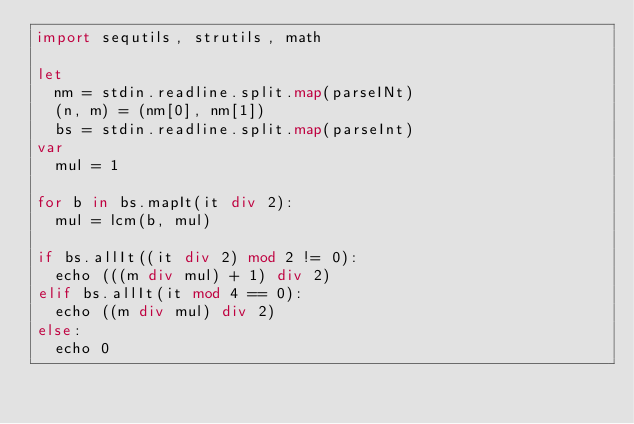<code> <loc_0><loc_0><loc_500><loc_500><_Nim_>import sequtils, strutils, math

let
  nm = stdin.readline.split.map(parseINt)
  (n, m) = (nm[0], nm[1])
  bs = stdin.readline.split.map(parseInt)
var
  mul = 1

for b in bs.mapIt(it div 2):
  mul = lcm(b, mul)

if bs.allIt((it div 2) mod 2 != 0):
  echo (((m div mul) + 1) div 2)
elif bs.allIt(it mod 4 == 0):
  echo ((m div mul) div 2)
else:
  echo 0
</code> 